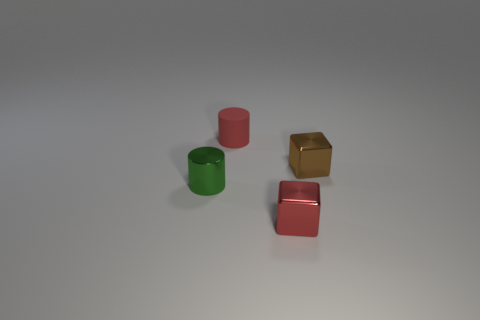What number of big things are brown metallic objects or blue metal spheres?
Ensure brevity in your answer.  0. What number of things are small shiny blocks that are behind the tiny red shiny block or blocks that are behind the green shiny object?
Provide a short and direct response. 1. Is the number of large cyan cylinders less than the number of red metallic objects?
Your response must be concise. Yes. What shape is the brown shiny thing that is the same size as the red shiny cube?
Make the answer very short. Cube. How many other things are the same color as the small rubber thing?
Give a very brief answer. 1. What number of red cylinders are there?
Your answer should be compact. 1. How many tiny red objects are both behind the red cube and in front of the small red cylinder?
Provide a short and direct response. 0. What material is the green object?
Offer a terse response. Metal. Are any large matte balls visible?
Give a very brief answer. No. There is a shiny thing on the left side of the small rubber object; what is its color?
Give a very brief answer. Green. 